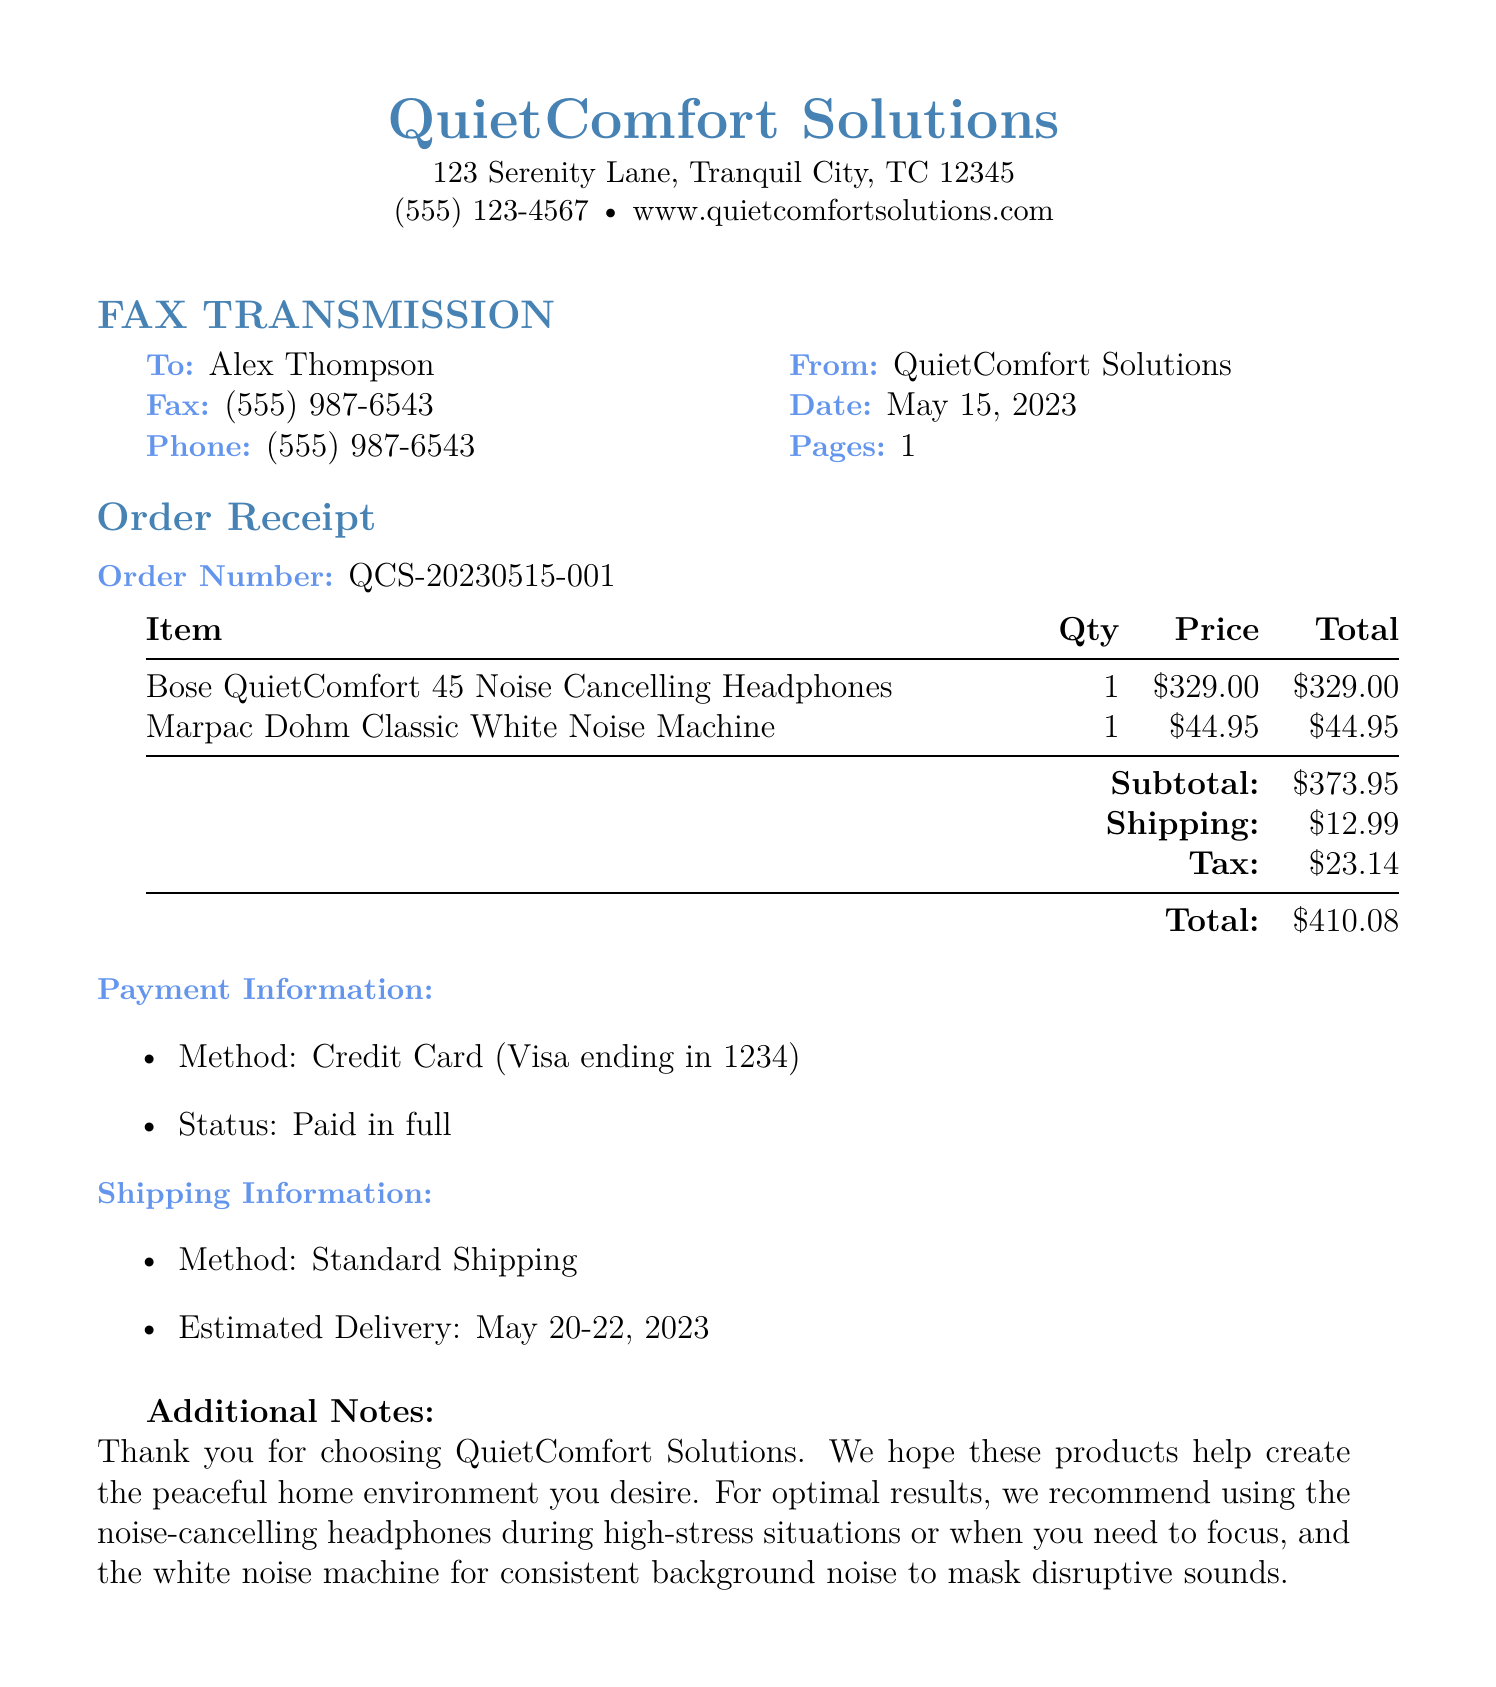what is the order number? The order number is provided in the receipt section of the document, specifically noted as QCS-20230515-001.
Answer: QCS-20230515-001 who is the recipient of the fax? The recipient of the fax is specified at the beginning, noted as Alex Thompson.
Answer: Alex Thompson what is the total amount of the order? The total amount is calculated by summing the subtotal, shipping, and tax, which is $373.95 + $12.99 + $23.14.
Answer: $410.08 how many items were purchased in total? The document lists two items purchased: the headphones and the white noise machine, totaling to a quantity of 2.
Answer: 2 when is the estimated delivery date? The estimated delivery date is mentioned in the shipping information section as May 20-22, 2023.
Answer: May 20-22, 2023 what type of shipping was used for the order? The method of shipping is stated in the shipping information section as Standard Shipping.
Answer: Standard Shipping what payment method was used for the order? The payment information section details that the method used was a Credit Card (Visa ending in 1234).
Answer: Credit Card (Visa ending in 1234) what is included in the additional notes section? The additional notes section thanks the customer and provides usage recommendations for the products purchased.
Answer: Thank you for choosing QuietComfort Solutions what company sent the fax? The company that sent the fax is identified at the top of the document as QuietComfort Solutions.
Answer: QuietComfort Solutions 